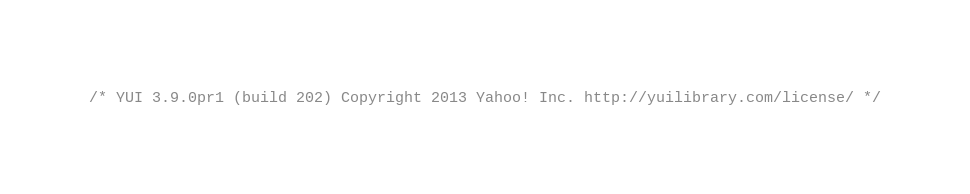<code> <loc_0><loc_0><loc_500><loc_500><_JavaScript_>/* YUI 3.9.0pr1 (build 202) Copyright 2013 Yahoo! Inc. http://yuilibrary.com/license/ */</code> 